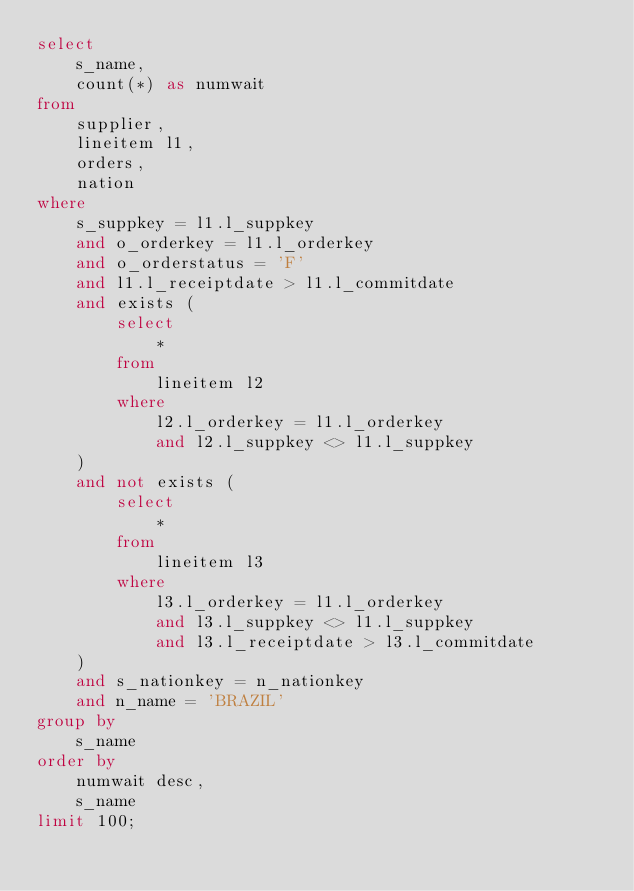Convert code to text. <code><loc_0><loc_0><loc_500><loc_500><_SQL_>select
	s_name,
	count(*) as numwait
from
	supplier,
	lineitem l1,
	orders,
	nation
where
	s_suppkey = l1.l_suppkey
	and o_orderkey = l1.l_orderkey
	and o_orderstatus = 'F'
	and l1.l_receiptdate > l1.l_commitdate
	and exists (
		select
			*
		from
			lineitem l2
		where
			l2.l_orderkey = l1.l_orderkey
			and l2.l_suppkey <> l1.l_suppkey
	)
	and not exists (
		select
			*
		from
			lineitem l3
		where
			l3.l_orderkey = l1.l_orderkey
			and l3.l_suppkey <> l1.l_suppkey
			and l3.l_receiptdate > l3.l_commitdate
	)
	and s_nationkey = n_nationkey
	and n_name = 'BRAZIL'
group by
	s_name
order by
	numwait desc,
	s_name
limit 100;</code> 